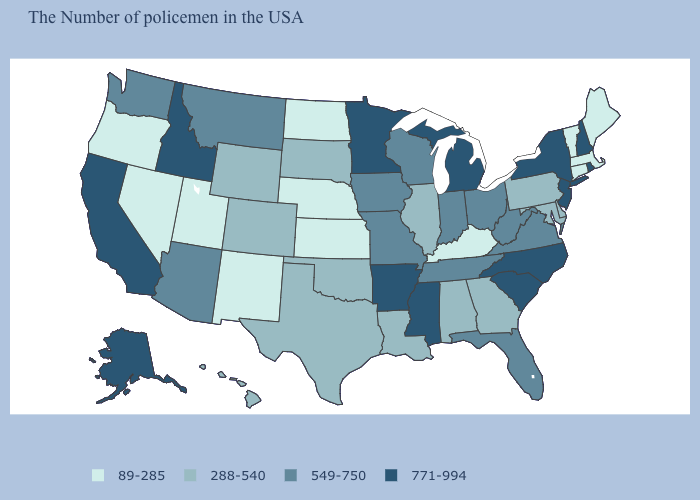Does Oregon have the highest value in the West?
Keep it brief. No. Does Hawaii have a lower value than Virginia?
Quick response, please. Yes. Among the states that border Virginia , does North Carolina have the highest value?
Give a very brief answer. Yes. Which states have the lowest value in the USA?
Answer briefly. Maine, Massachusetts, Vermont, Connecticut, Kentucky, Kansas, Nebraska, North Dakota, New Mexico, Utah, Nevada, Oregon. Which states have the lowest value in the USA?
Keep it brief. Maine, Massachusetts, Vermont, Connecticut, Kentucky, Kansas, Nebraska, North Dakota, New Mexico, Utah, Nevada, Oregon. How many symbols are there in the legend?
Give a very brief answer. 4. What is the value of California?
Answer briefly. 771-994. What is the lowest value in the Northeast?
Answer briefly. 89-285. Is the legend a continuous bar?
Give a very brief answer. No. What is the highest value in the USA?
Quick response, please. 771-994. Name the states that have a value in the range 288-540?
Give a very brief answer. Delaware, Maryland, Pennsylvania, Georgia, Alabama, Illinois, Louisiana, Oklahoma, Texas, South Dakota, Wyoming, Colorado, Hawaii. Among the states that border Montana , which have the lowest value?
Write a very short answer. North Dakota. Name the states that have a value in the range 89-285?
Quick response, please. Maine, Massachusetts, Vermont, Connecticut, Kentucky, Kansas, Nebraska, North Dakota, New Mexico, Utah, Nevada, Oregon. Name the states that have a value in the range 89-285?
Answer briefly. Maine, Massachusetts, Vermont, Connecticut, Kentucky, Kansas, Nebraska, North Dakota, New Mexico, Utah, Nevada, Oregon. Does South Carolina have the highest value in the South?
Be succinct. Yes. 